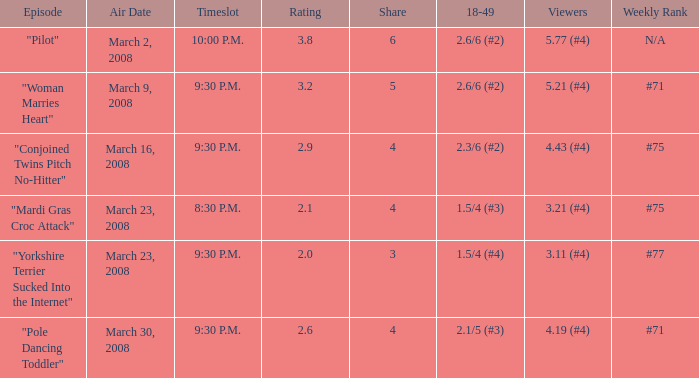What is the overall rating on shares under 4? 1.0. 